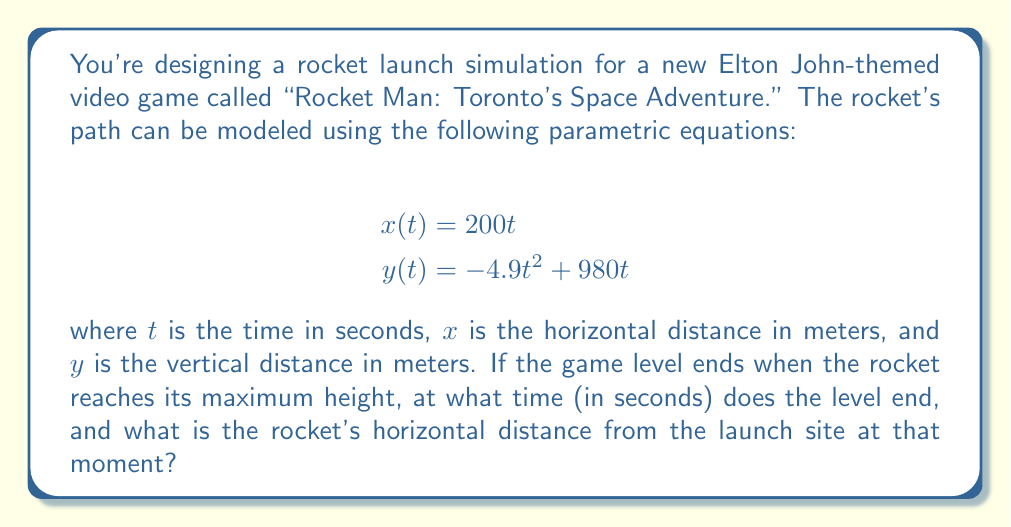Can you answer this question? To solve this problem, we need to follow these steps:

1) First, we need to find when the rocket reaches its maximum height. This occurs when the vertical velocity is zero. We can find this by taking the derivative of $y(t)$ with respect to $t$ and setting it equal to zero:

   $$\frac{dy}{dt} = -9.8t + 980 = 0$$

2) Solving this equation:
   $$-9.8t + 980 = 0$$
   $$9.8t = 980$$
   $$t = 100$$

3) So, the rocket reaches its maximum height at $t = 100$ seconds. This is when the level ends.

4) To find the horizontal distance at this time, we simply plug $t = 100$ into the equation for $x(t)$:

   $$x(100) = 200(100) = 20,000$$

Therefore, when the rocket is at its maximum height, it is 20,000 meters horizontally from the launch site.
Answer: The level ends at $t = 100$ seconds, and the rocket's horizontal distance from the launch site at that moment is 20,000 meters. 